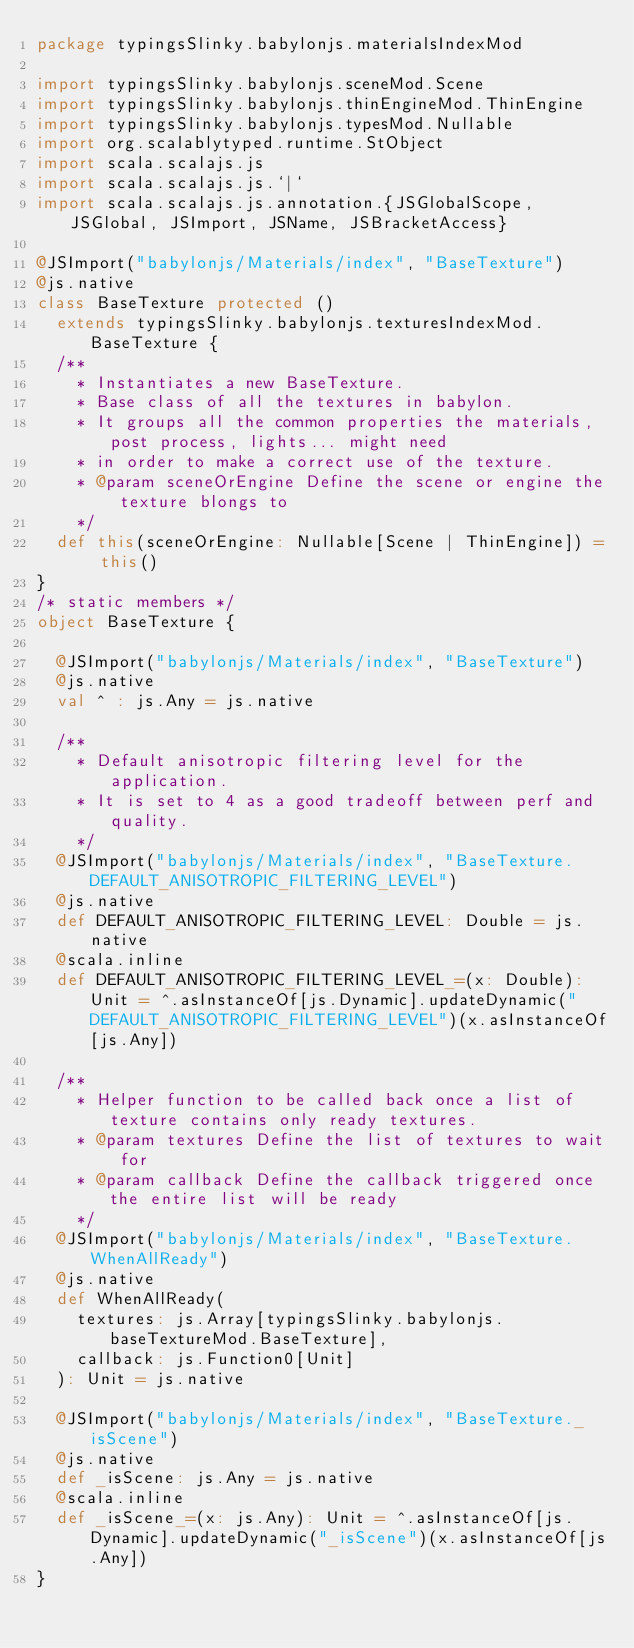<code> <loc_0><loc_0><loc_500><loc_500><_Scala_>package typingsSlinky.babylonjs.materialsIndexMod

import typingsSlinky.babylonjs.sceneMod.Scene
import typingsSlinky.babylonjs.thinEngineMod.ThinEngine
import typingsSlinky.babylonjs.typesMod.Nullable
import org.scalablytyped.runtime.StObject
import scala.scalajs.js
import scala.scalajs.js.`|`
import scala.scalajs.js.annotation.{JSGlobalScope, JSGlobal, JSImport, JSName, JSBracketAccess}

@JSImport("babylonjs/Materials/index", "BaseTexture")
@js.native
class BaseTexture protected ()
  extends typingsSlinky.babylonjs.texturesIndexMod.BaseTexture {
  /**
    * Instantiates a new BaseTexture.
    * Base class of all the textures in babylon.
    * It groups all the common properties the materials, post process, lights... might need
    * in order to make a correct use of the texture.
    * @param sceneOrEngine Define the scene or engine the texture blongs to
    */
  def this(sceneOrEngine: Nullable[Scene | ThinEngine]) = this()
}
/* static members */
object BaseTexture {
  
  @JSImport("babylonjs/Materials/index", "BaseTexture")
  @js.native
  val ^ : js.Any = js.native
  
  /**
    * Default anisotropic filtering level for the application.
    * It is set to 4 as a good tradeoff between perf and quality.
    */
  @JSImport("babylonjs/Materials/index", "BaseTexture.DEFAULT_ANISOTROPIC_FILTERING_LEVEL")
  @js.native
  def DEFAULT_ANISOTROPIC_FILTERING_LEVEL: Double = js.native
  @scala.inline
  def DEFAULT_ANISOTROPIC_FILTERING_LEVEL_=(x: Double): Unit = ^.asInstanceOf[js.Dynamic].updateDynamic("DEFAULT_ANISOTROPIC_FILTERING_LEVEL")(x.asInstanceOf[js.Any])
  
  /**
    * Helper function to be called back once a list of texture contains only ready textures.
    * @param textures Define the list of textures to wait for
    * @param callback Define the callback triggered once the entire list will be ready
    */
  @JSImport("babylonjs/Materials/index", "BaseTexture.WhenAllReady")
  @js.native
  def WhenAllReady(
    textures: js.Array[typingsSlinky.babylonjs.baseTextureMod.BaseTexture],
    callback: js.Function0[Unit]
  ): Unit = js.native
  
  @JSImport("babylonjs/Materials/index", "BaseTexture._isScene")
  @js.native
  def _isScene: js.Any = js.native
  @scala.inline
  def _isScene_=(x: js.Any): Unit = ^.asInstanceOf[js.Dynamic].updateDynamic("_isScene")(x.asInstanceOf[js.Any])
}
</code> 